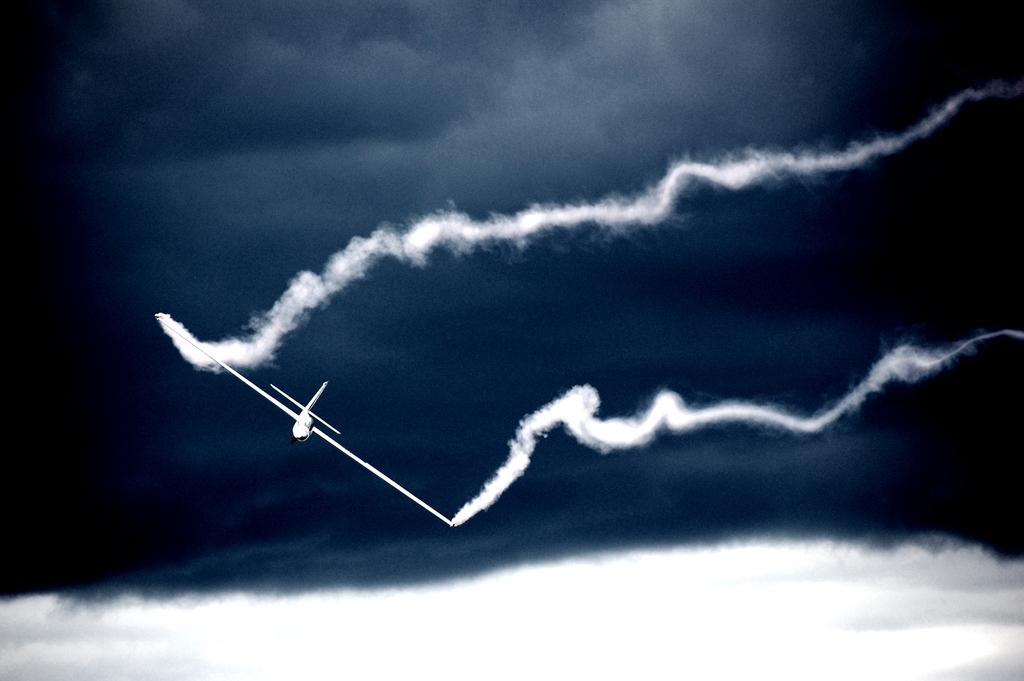What is the main subject of the image? The main subject of the image is an airplane. What can be seen in the background of the image? There are clouds and smoke visible in the background of the image. What type of scale is used to weigh the airplane in the image? There is no scale present in the image, and the weight of the airplane is not mentioned or depicted. 